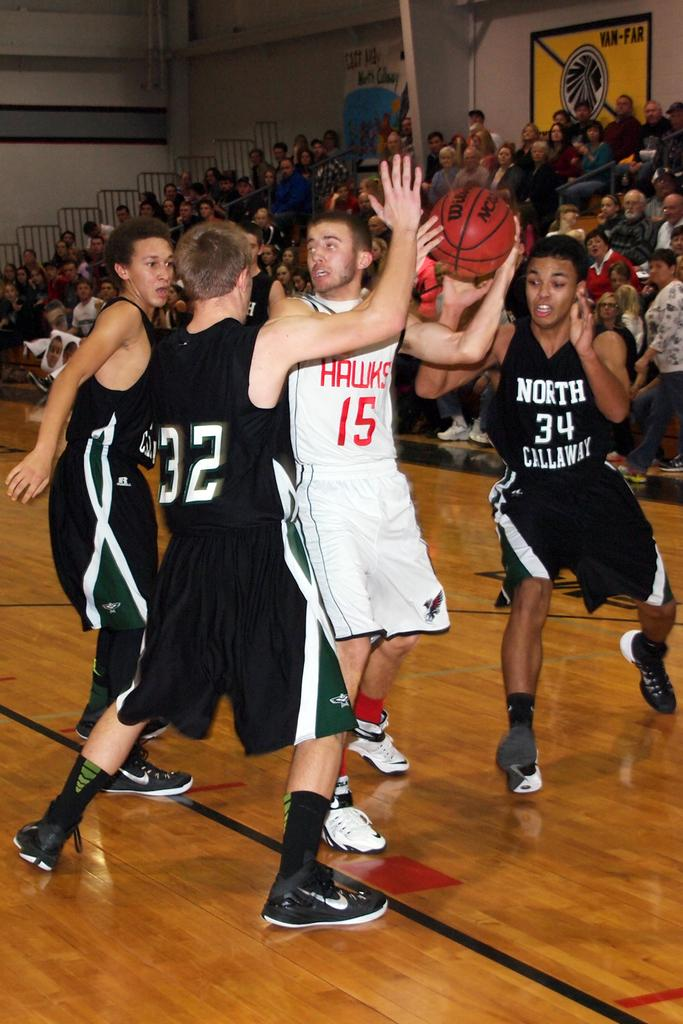<image>
Write a terse but informative summary of the picture. A defender from North Callaway reaches for a ball against the Hawks. 